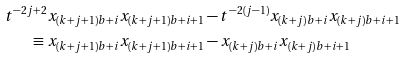Convert formula to latex. <formula><loc_0><loc_0><loc_500><loc_500>t ^ { - 2 j + 2 } x _ { ( k + j + 1 ) b + i } x _ { ( k + j + 1 ) b + i + 1 } & - t ^ { - 2 ( j - 1 ) } x _ { ( k + j ) b + i } x _ { ( k + j ) b + i + 1 } \\ \equiv x _ { ( k + j + 1 ) b + i } x _ { ( k + j + 1 ) b + i + 1 } & - x _ { ( k + j ) b + i } x _ { ( k + j ) b + i + 1 }</formula> 